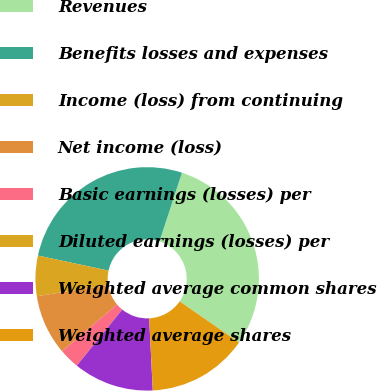Convert chart to OTSL. <chart><loc_0><loc_0><loc_500><loc_500><pie_chart><fcel>Revenues<fcel>Benefits losses and expenses<fcel>Income (loss) from continuing<fcel>Net income (loss)<fcel>Basic earnings (losses) per<fcel>Diluted earnings (losses) per<fcel>Weighted average common shares<fcel>Weighted average shares<nl><fcel>29.61%<fcel>26.7%<fcel>5.83%<fcel>8.74%<fcel>2.92%<fcel>0.01%<fcel>11.65%<fcel>14.56%<nl></chart> 